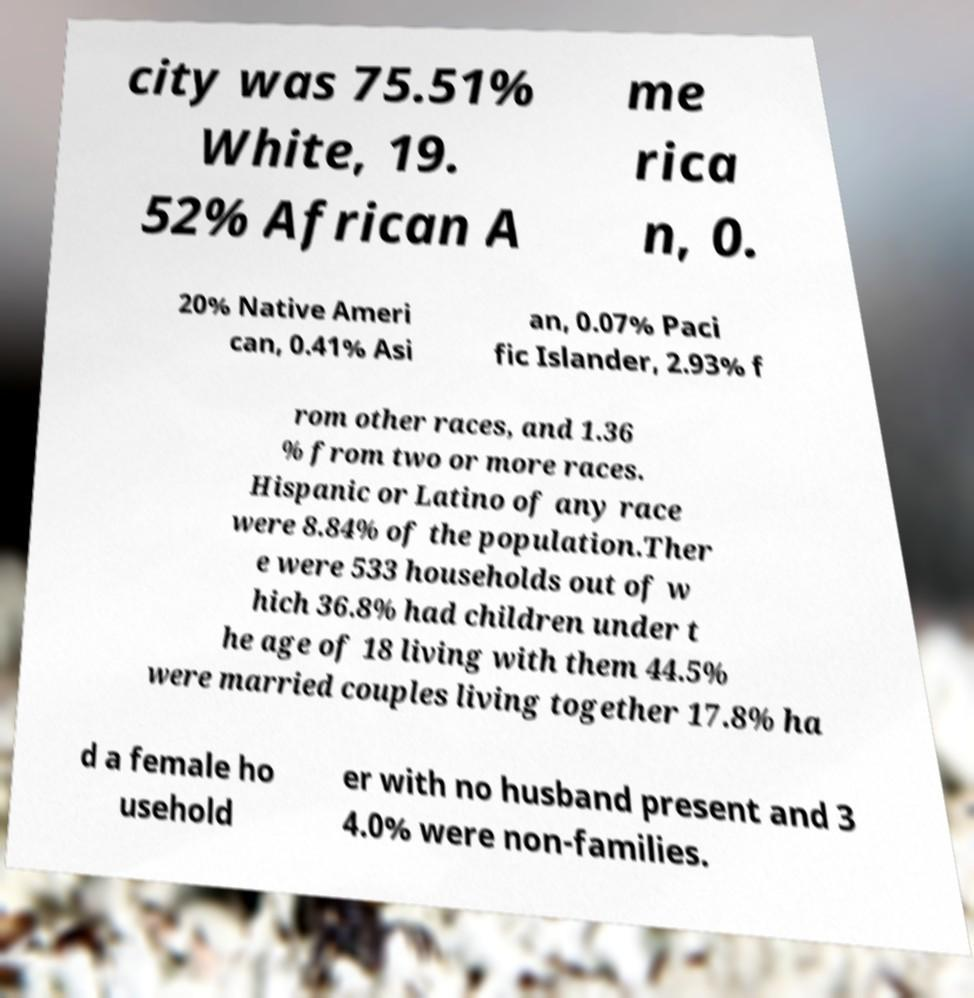For documentation purposes, I need the text within this image transcribed. Could you provide that? city was 75.51% White, 19. 52% African A me rica n, 0. 20% Native Ameri can, 0.41% Asi an, 0.07% Paci fic Islander, 2.93% f rom other races, and 1.36 % from two or more races. Hispanic or Latino of any race were 8.84% of the population.Ther e were 533 households out of w hich 36.8% had children under t he age of 18 living with them 44.5% were married couples living together 17.8% ha d a female ho usehold er with no husband present and 3 4.0% were non-families. 